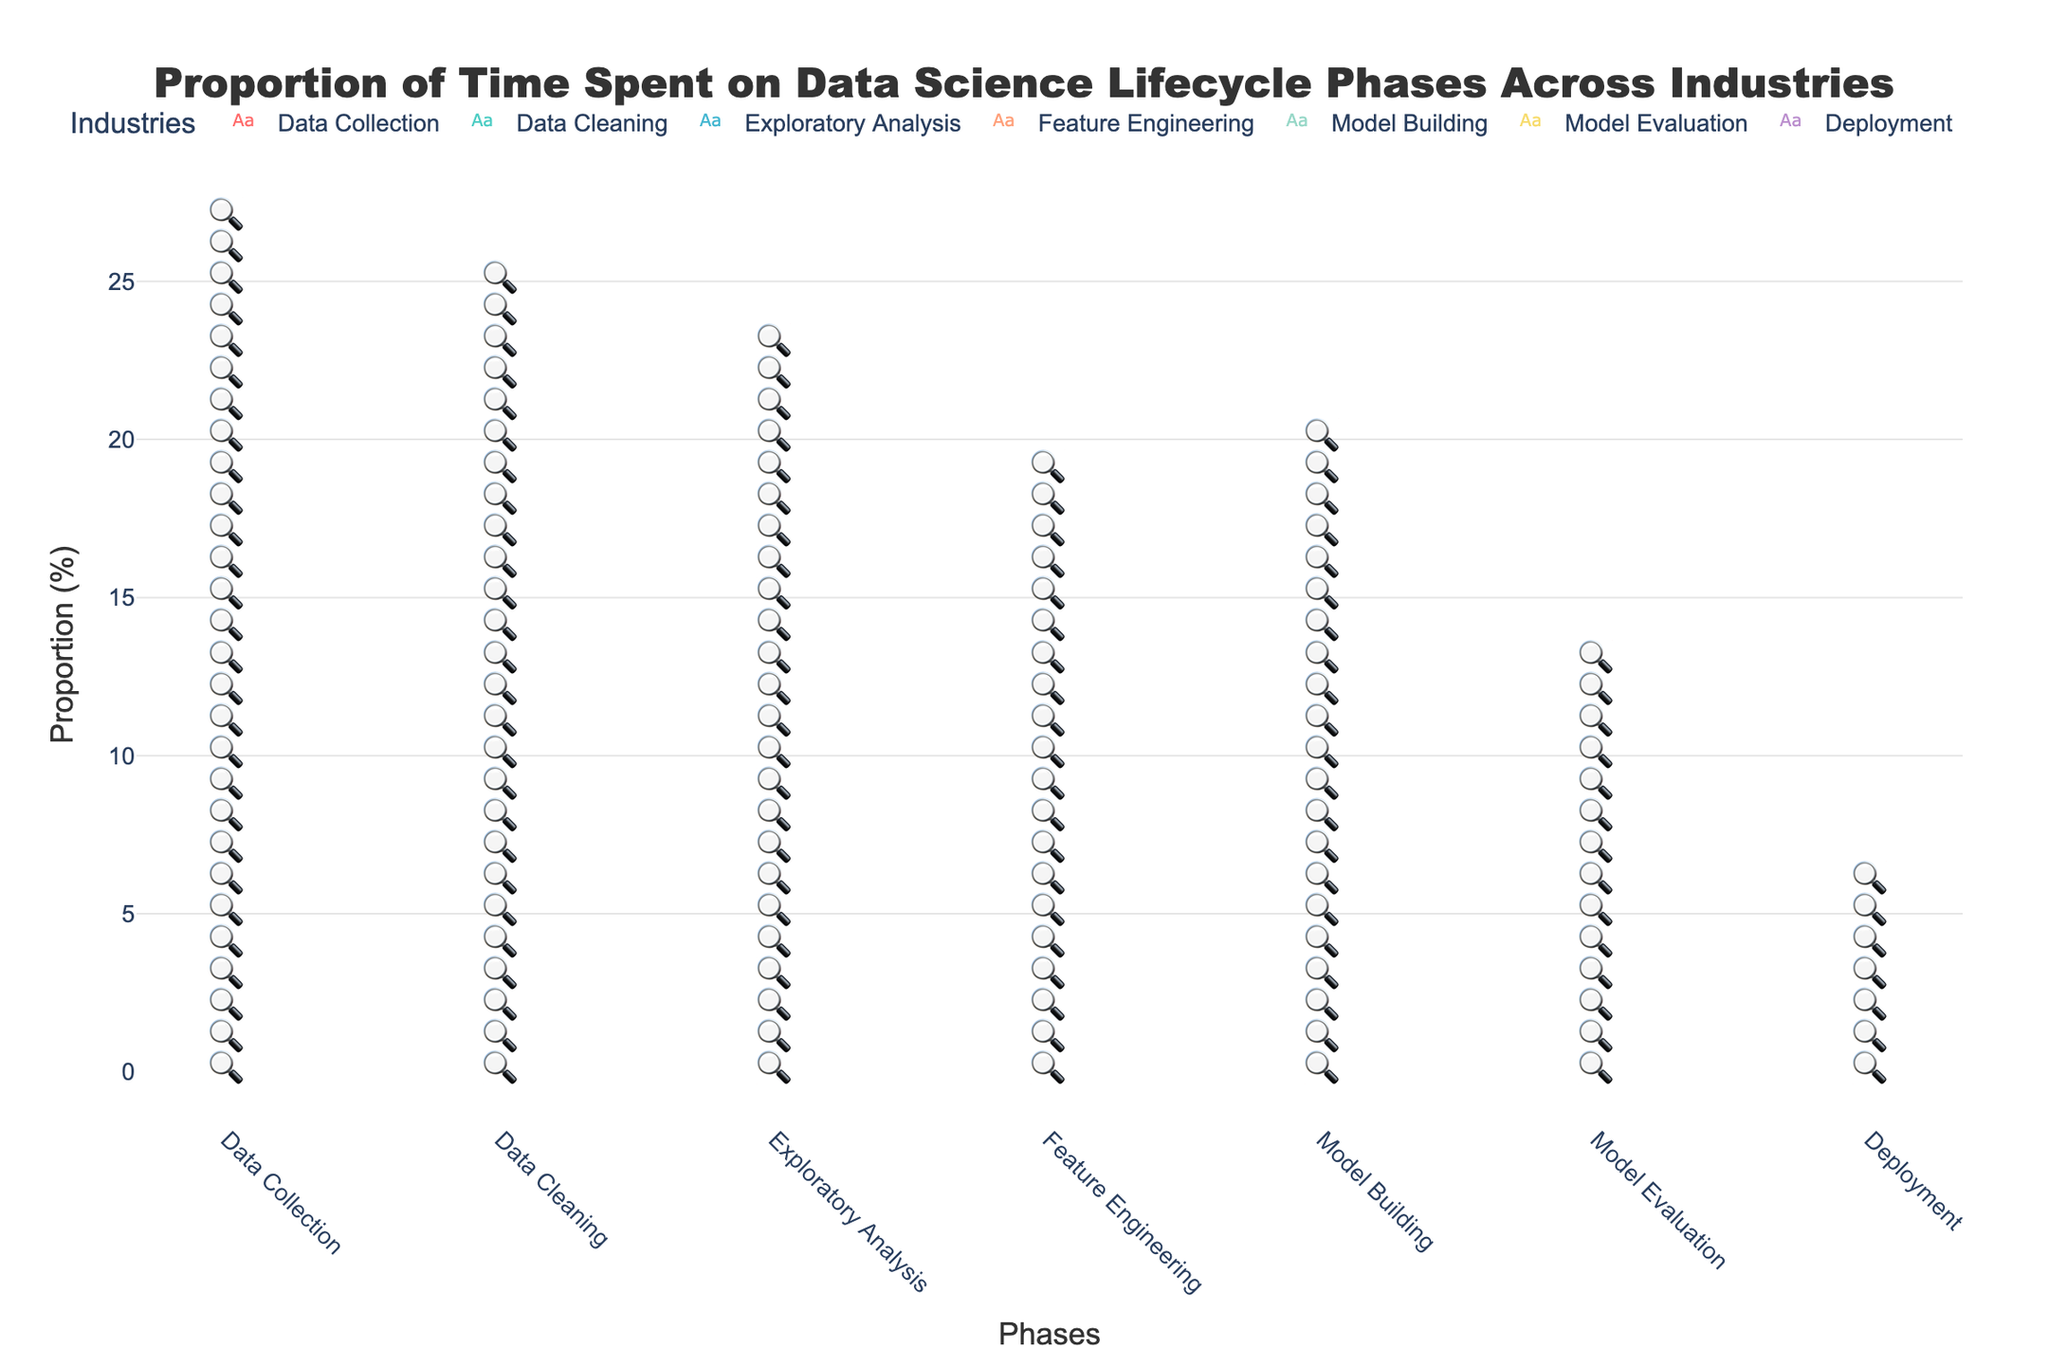What is the title of the figure? The title is usually located at the top of the figure. It summarizes what the figure represents.
Answer: Proportion of Time Spent on Data Science Lifecycle Phases Across Industries Which industry spends the most time on Data Cleaning? By counting the number of icons representing Data Cleaning for each industry, the Healthcare industry has the highest number.
Answer: Healthcare Which phase does the Technology industry spend the most time on? Look at the phases for Technology and count the icons. Model Building has the most icons.
Answer: Model Building What is the total proportion of time the Finance industry spends on Data Collection and Deployment? Sum the proportion of time spent on these two phases for Finance. Data Collection (20%) + Deployment (5%) = 25%.
Answer: 25% Which phase has the least variation in time spent across all industries? Calculate the range for each phase by finding the difference between the max and min values across industries. Deployment has the least variation with a range of 0% as all industries spend 5%.
Answer: Deployment How does the proportion of time spent on Feature Engineering in Manufacturing compare to that in Finance? Compare these two values directly. Manufacturing spends 20%, Finance spends 15%.
Answer: Manufacturing spends 5% more What is the average proportion of time spent on Model Evaluation across all industries? Sum all proportions for Model Evaluation (10+10+10+10+10+10+10) and then divide by the number of industries (7). 70% / 7 = 10%.
Answer: 10% Across which industry is the Exploratory Analysis phase the most varied in time spent? Calculate or compare the difference in values of Exploratory Analysis across industries. Both Finance and Telecommunications have the highest value of 20 and lowest value of 10, giving a range of 10%.
Answer: Finance and Telecommunications If you combine the time spent on Data Collection and Exploratory Analysis, which industry allocates the highest proportion? Sum both phases for each industry and compare. Retail: 25+15=40%, Telecommunications: 25+20=45%. Telecommunications allocates the highest proportion.
Answer: Telecommunications Which phases have equal time allocated by more than one industry and which industries are they? Look for repeated proportions in phases across industries. Data Collection (20%) is shared by Finance and Manufacturing. Model Evaluation (10%) is common across all industries.
Answer: Data Collection: Finance & Manufacturing; Model Evaluation: All industries 